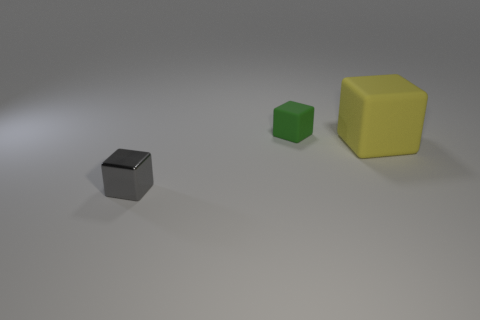Add 3 small cyan blocks. How many objects exist? 6 Subtract all small blocks. How many blocks are left? 1 Subtract 2 blocks. How many blocks are left? 1 Subtract 1 green cubes. How many objects are left? 2 Subtract all purple cubes. Subtract all red cylinders. How many cubes are left? 3 Subtract all large yellow things. Subtract all yellow rubber cubes. How many objects are left? 1 Add 3 tiny rubber cubes. How many tiny rubber cubes are left? 4 Add 1 small brown rubber objects. How many small brown rubber objects exist? 1 